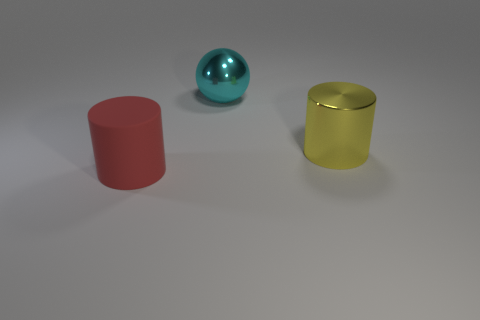Add 2 big purple matte objects. How many objects exist? 5 Subtract all cylinders. How many objects are left? 1 Add 3 purple cylinders. How many purple cylinders exist? 3 Subtract 1 cyan spheres. How many objects are left? 2 Subtract all small matte cylinders. Subtract all red matte objects. How many objects are left? 2 Add 1 big metal objects. How many big metal objects are left? 3 